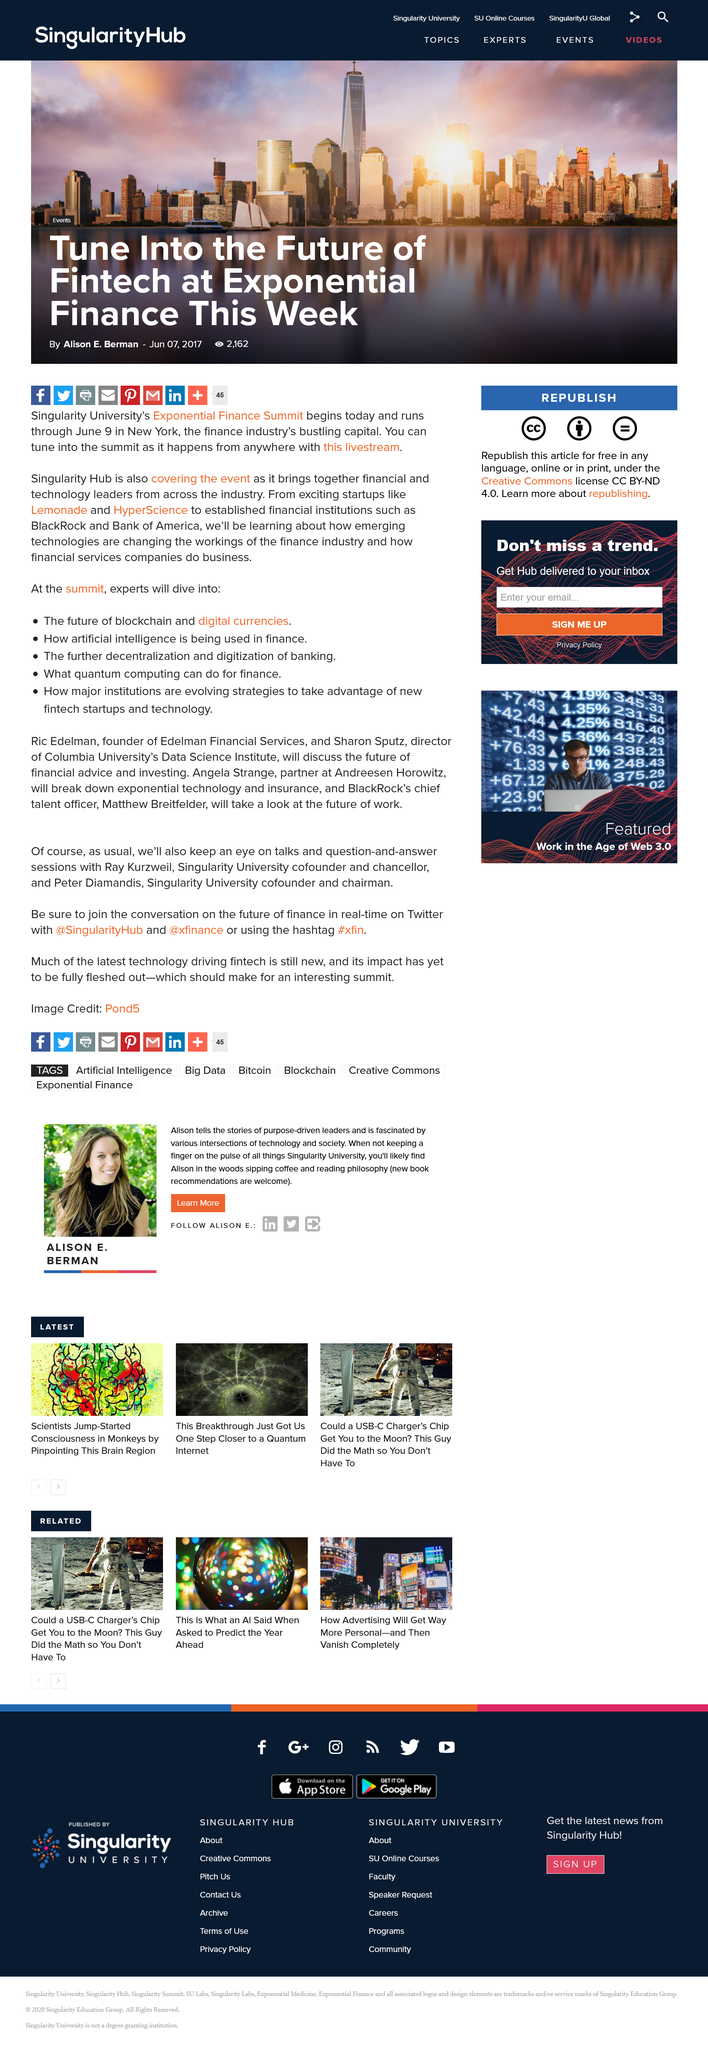Highlight a few significant elements in this photo. The Exponential Finance Summit will be held in New York City. I know of two startup companies, Lemonade and HyperScience, that will be attending the Exponential Finance Summit this week. The Exponential Finance Summit is expected to last for a duration of three days. 